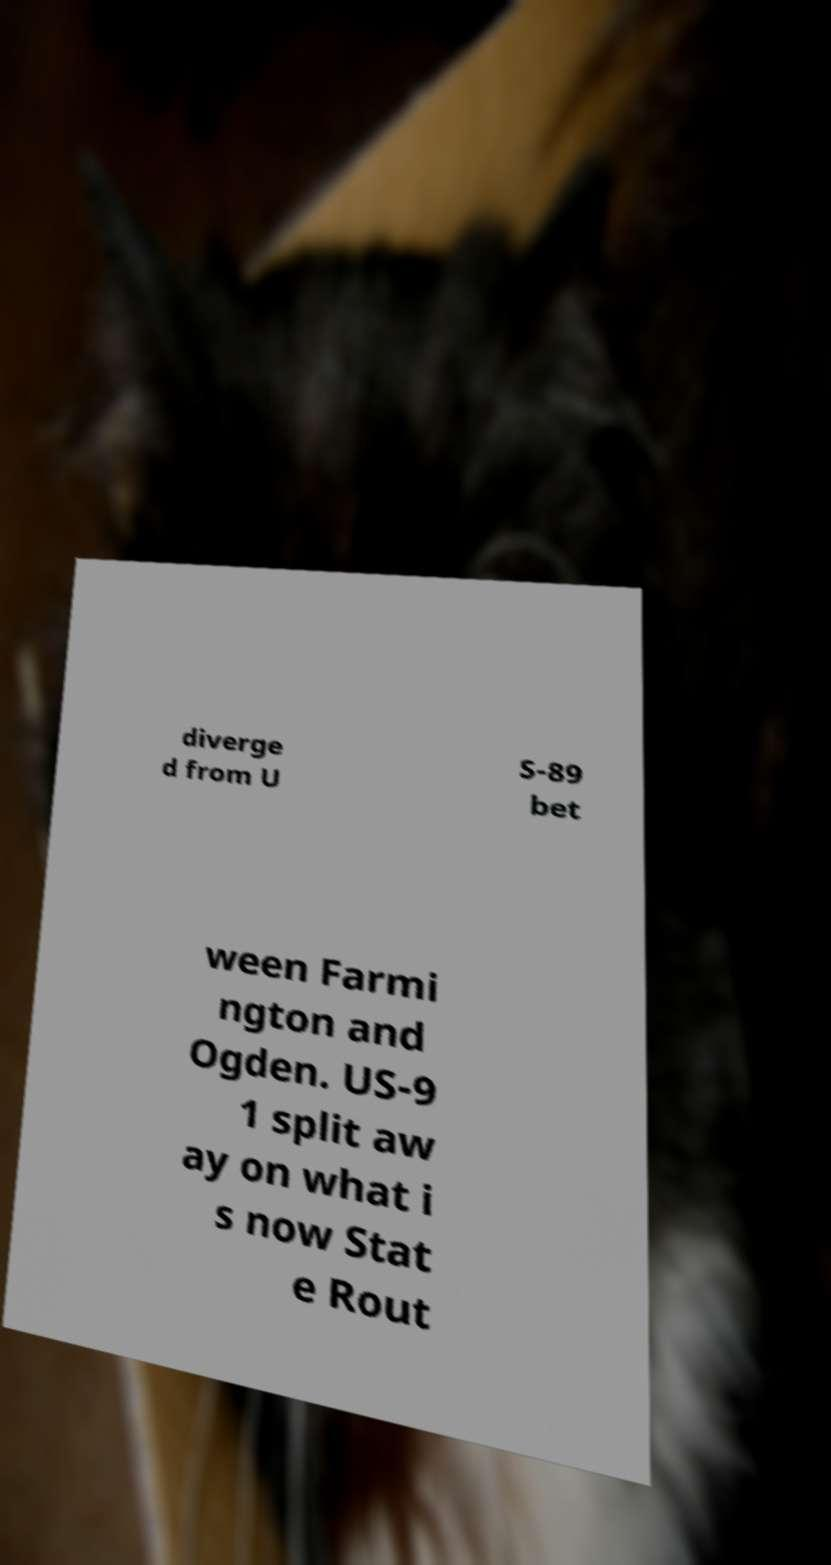What messages or text are displayed in this image? I need them in a readable, typed format. diverge d from U S-89 bet ween Farmi ngton and Ogden. US-9 1 split aw ay on what i s now Stat e Rout 